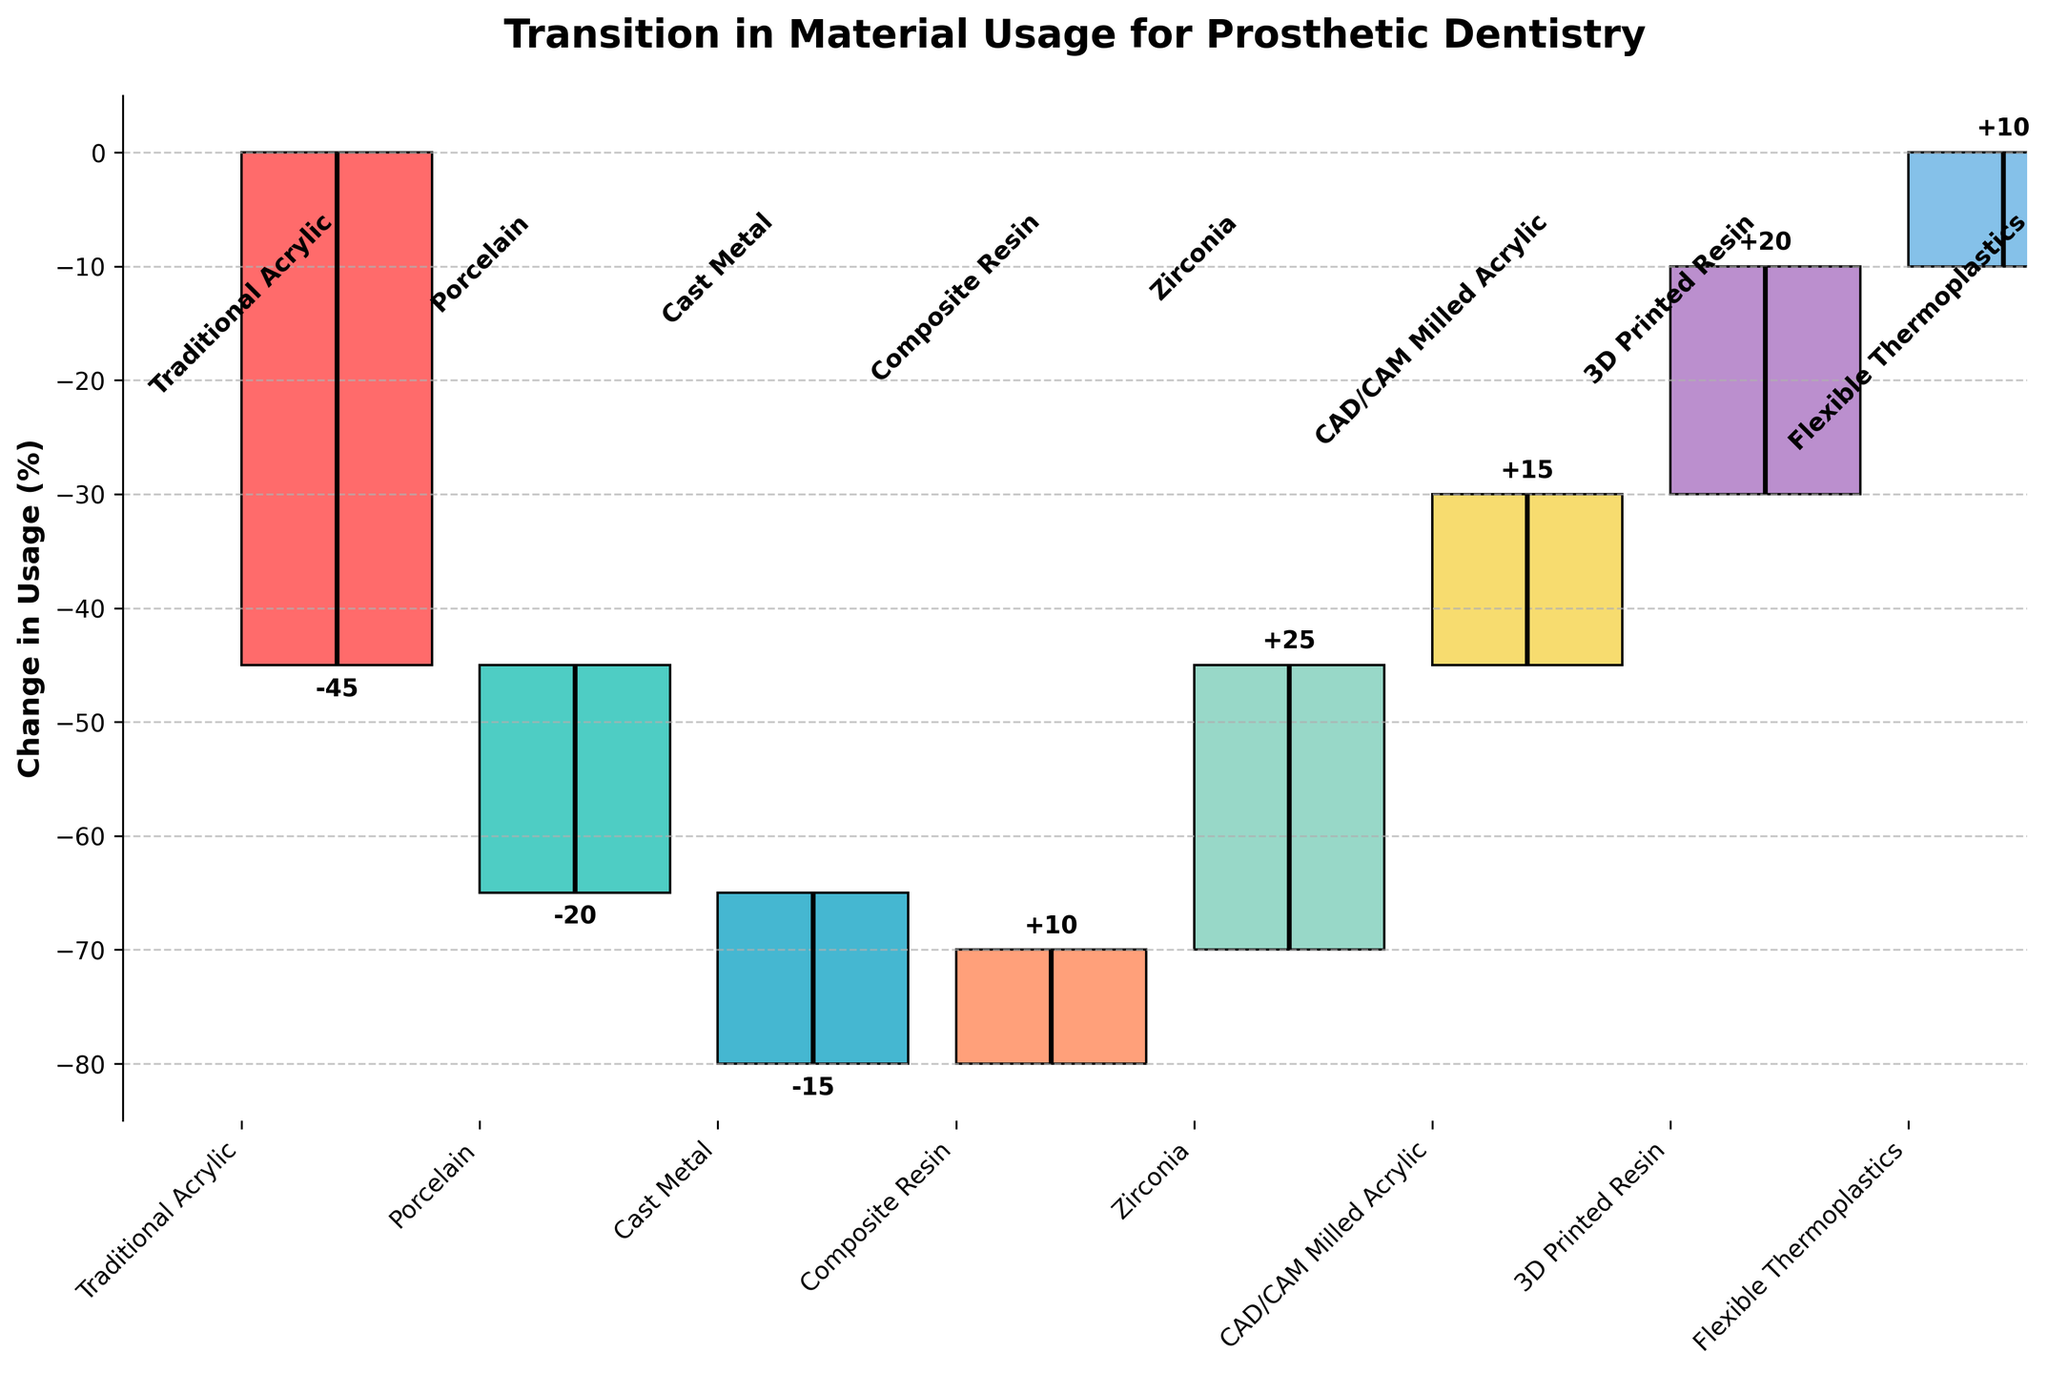How many materials are represented in the Waterfall Chart? There are 8 bars visible in the figure, each representing a different material.
Answer: 8 What is the overall title of the Waterfall Chart? The title is written at the top of the chart.
Answer: Transition in Material Usage for Prosthetic Dentistry Which material shows the greatest increase in usage? By looking at the length of the positive bars, the longest bar represents Zirconia.
Answer: Zirconia Which materials show a decrease in usage? The bars that drop from the initial position represent a decrease. These are Traditional Acrylic, Porcelain, and Cast Metal.
Answer: Traditional Acrylic, Porcelain, Cast Metal What is the cumulative change in usage for all materials? Sum all the changes provided: -45 (Traditional Acrylic) - 20 (Porcelain) - 15 (Cast Metal) + 10 (Composite Resin) + 25 (Zirconia) + 15 (CAD/CAM Milled Acrylic) + 20 (3D Printed Resin) + 10 (Flexible Thermoplastics) = 0
Answer: 0 Which material shows an increase in usage, but has the smallest change among all materials that show an increase? Identify the smallest positive change, which is for Composite Resin with a change of +10.
Answer: Composite Resin What is the height of the bar that represents the usage change of Cast Metal? The bar is located third from the left and shows a height of -15.
Answer: -15 How does the bar of 3D Printed Resin compare to CAD/CAM Milled Acrylic in terms of change? 3D Printed Resin has a change of +20, while CAD/CAM Milled Acrylic has +15. 3D Printed Resin shows a greater change.
Answer: 3D Printed Resin What is the total increase in usage for modern materials (Composite Resin, Zirconia, CAD/CAM Milled Acrylic, 3D Printed Resin, Flexible Thermoplastics)? Sum their changes: 10 (Composite Resin) + 25 (Zirconia) + 15 (CAD/CAM Milled Acrylic) + 20 (3D Printed Resin) + 10 (Flexible Thermoplastics) = 80
Answer: 80 